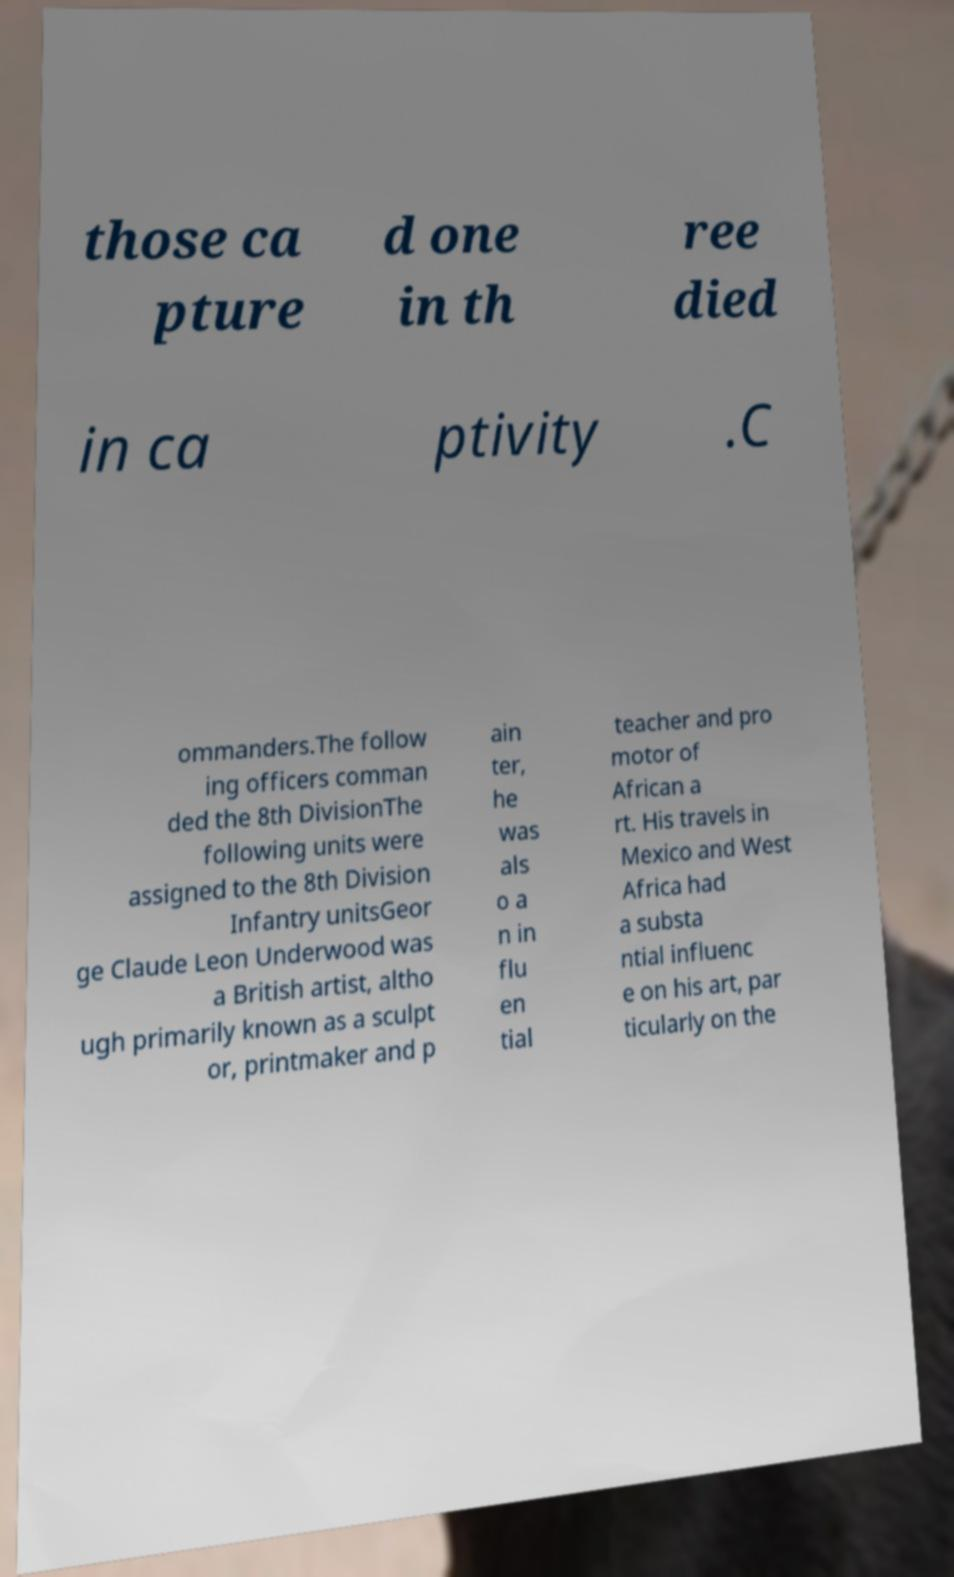Can you accurately transcribe the text from the provided image for me? those ca pture d one in th ree died in ca ptivity .C ommanders.The follow ing officers comman ded the 8th DivisionThe following units were assigned to the 8th Division Infantry unitsGeor ge Claude Leon Underwood was a British artist, altho ugh primarily known as a sculpt or, printmaker and p ain ter, he was als o a n in flu en tial teacher and pro motor of African a rt. His travels in Mexico and West Africa had a substa ntial influenc e on his art, par ticularly on the 